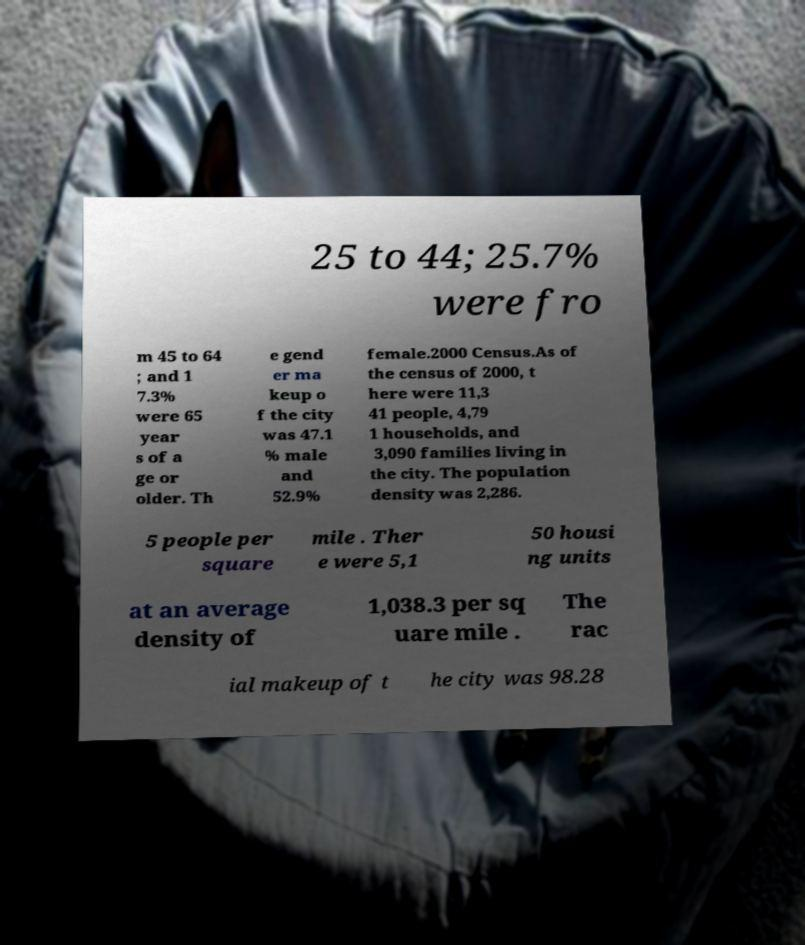Could you extract and type out the text from this image? 25 to 44; 25.7% were fro m 45 to 64 ; and 1 7.3% were 65 year s of a ge or older. Th e gend er ma keup o f the city was 47.1 % male and 52.9% female.2000 Census.As of the census of 2000, t here were 11,3 41 people, 4,79 1 households, and 3,090 families living in the city. The population density was 2,286. 5 people per square mile . Ther e were 5,1 50 housi ng units at an average density of 1,038.3 per sq uare mile . The rac ial makeup of t he city was 98.28 